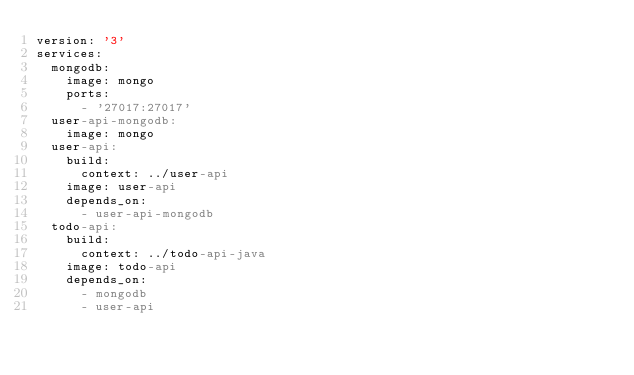Convert code to text. <code><loc_0><loc_0><loc_500><loc_500><_YAML_>version: '3'
services:
  mongodb:
    image: mongo
    ports:
      - '27017:27017'
  user-api-mongodb:
    image: mongo
  user-api:
    build:
      context: ../user-api
    image: user-api
    depends_on:
      - user-api-mongodb
  todo-api:
    build:
      context: ../todo-api-java
    image: todo-api
    depends_on:
      - mongodb
      - user-api
</code> 